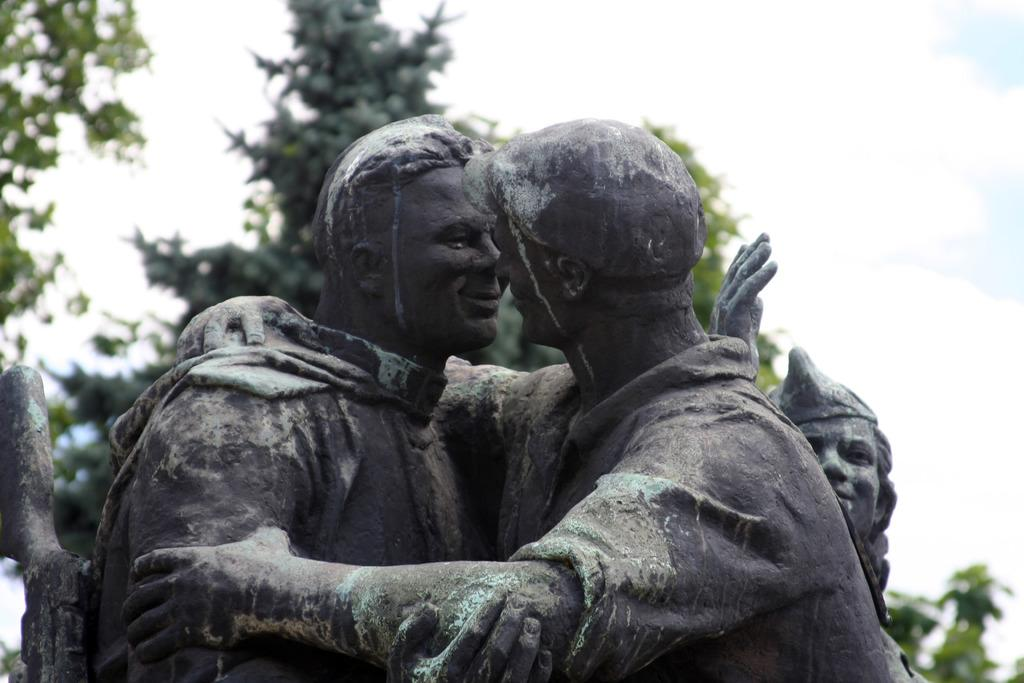Who or what can be seen in the image? There are persons depicted in the image. What type of natural environment is visible in the background? There are trees in the background of the image. What else can be seen in the background of the image? The sky is visible in the background of the image. What is the condition of the sky in the image? Clouds are present in the sky. What type of nut is being used as a prop in the image? There is no nut present in the image. 